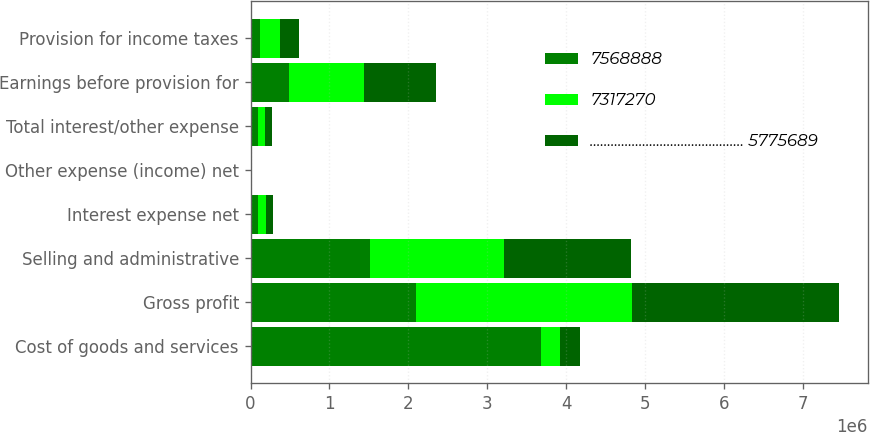<chart> <loc_0><loc_0><loc_500><loc_500><stacked_bar_chart><ecel><fcel>Cost of goods and services<fcel>Gross profit<fcel>Selling and administrative<fcel>Interest expense net<fcel>Other expense (income) net<fcel>Total interest/other expense<fcel>Earnings before provision for<fcel>Provision for income taxes<nl><fcel>7568888<fcel>3.67654e+06<fcel>2.09915e+06<fcel>1.51111e+06<fcel>100375<fcel>3950<fcel>96425<fcel>491618<fcel>119724<nl><fcel>7317270<fcel>246939<fcel>2.73001e+06<fcel>1.70068e+06<fcel>96037<fcel>12726<fcel>83311<fcel>946019<fcel>251261<nl><fcel>............................................ 5775689<fcel>246939<fcel>2.6195e+06<fcel>1.614e+06<fcel>89589<fcel>3541<fcel>93130<fcel>912367<fcel>242617<nl></chart> 